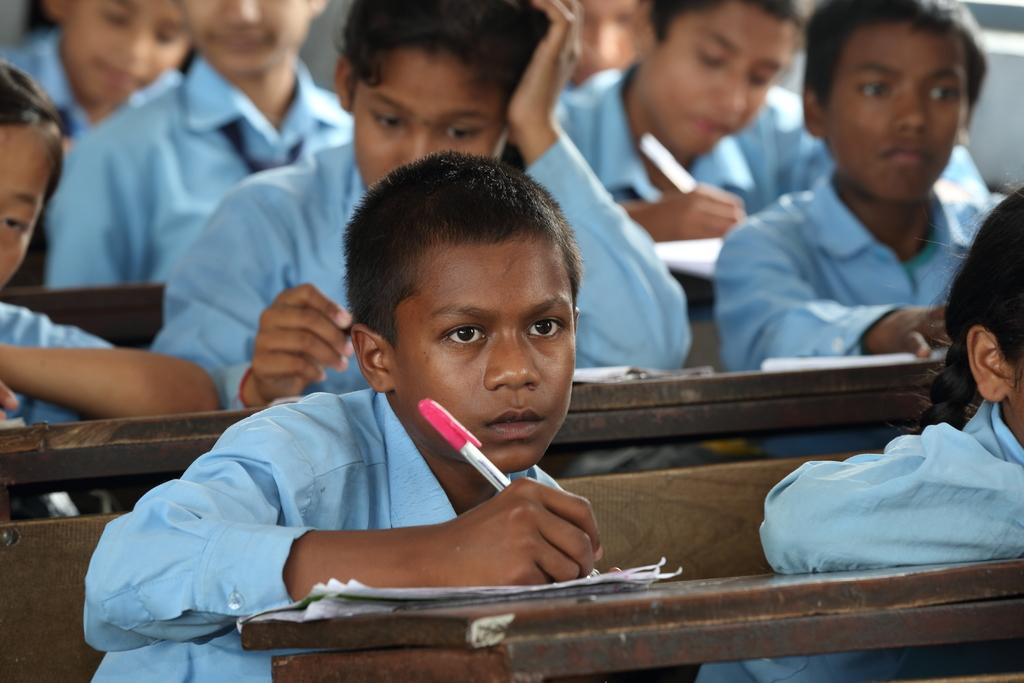What is the main subject of the image? The main subject of the image is a group of students. What are the students doing in the image? The students are sitting on benches and writing on papers. What type of insect can be seen crawling on the students' papers in the image? There are no insects present in the image; the students are simply writing on their papers. 